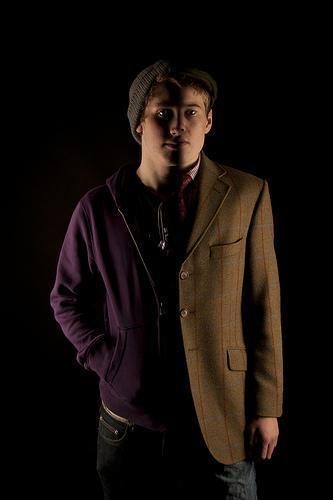How many different people are pictured?
Give a very brief answer. 2. 